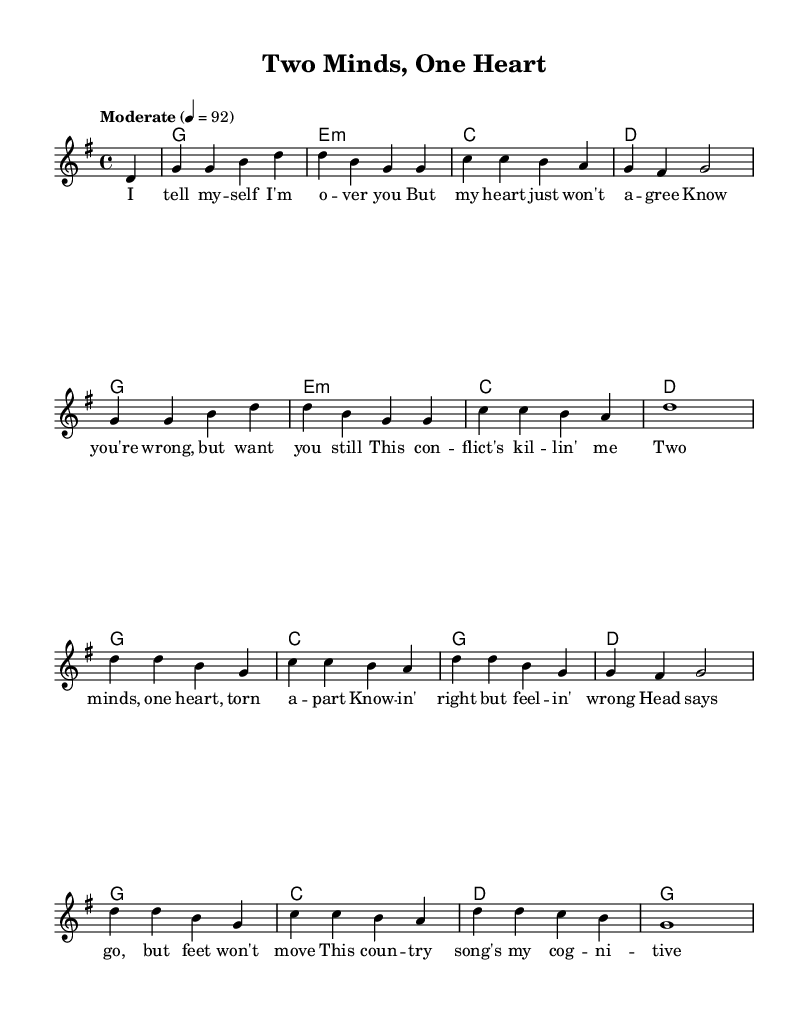What is the key signature of this music? The key signature is G major, which has one sharp (F#). This can be identified by looking at the key signature indicated at the beginning of the sheet music.
Answer: G major What is the time signature of this piece? The time signature is 4/4, which can be found noted at the beginning of the score next to the key signature. It indicates that there are four beats per measure.
Answer: 4/4 What is the tempo marking for the music? The tempo marking states "Moderate" with a metronome indication of 92 beats per minute. This is expressed in the tempo section of the score where it sets the speed of the performance.
Answer: Moderate How many measures are in the melody section? The melody section has a total of 16 measures, as counted from the beginning to the end of the melody notation. Each measure is separated by vertical lines.
Answer: 16 What is the main theme of the chorus lyrics? The main theme of the chorus lyrics revolves around cognitive dissonance, expressing feelings of conflict between head and heart. This can be identified from the lyrics' content, which discusses these opposing feelings.
Answer: Cognitive dissonance Which chord is used in the first measure of the harmony? The first chord used in the harmony is G major, as indicated by the chord symbols written in the chord section alongside the melody.
Answer: G major What lyrical conflict is highlighted in the song? The lyrical conflict highlighted in the song is the struggle between knowing what's right and feeling something different, emphasizing the tension of cognitive dissonance. This can be inferred from the lyrics that reflect conflicting emotions.
Answer: Cognitive dissonance 